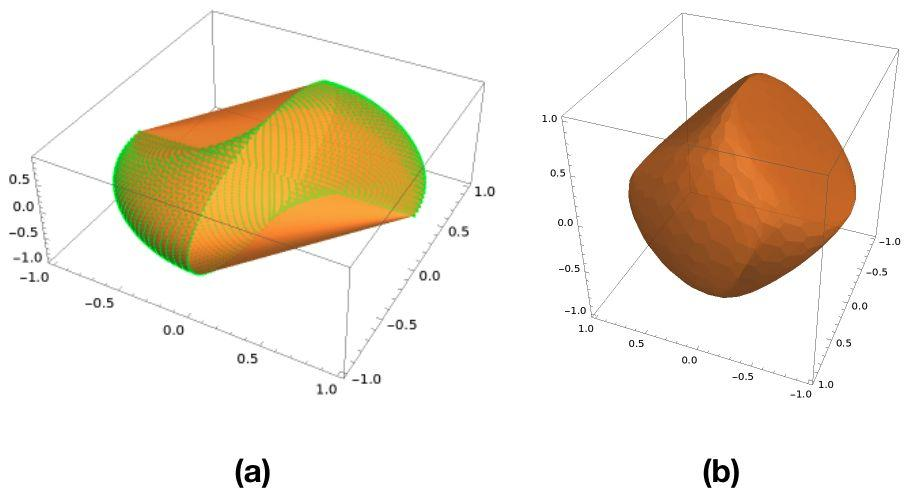What characteristic of the surface in Figure (a) distinguishes it from the surface in Figure (b)? A. Figure (a) has a flat surface, while Figure (b) has a curved surface. B. Figure (a) is a two-dimensional plot, while Figure (b) is a three-dimensional plot. C. Figure (a) shows a surface with only positive z-values, while Figure (b) includes both positive and negative z-values. D. Figure (a) shows a sinusoidal pattern, while Figure (b) is a solid without a visible pattern. Figure (a) displays a clear sinusoidal pattern across its surface, indicated by the alternating colors representing different heights (z-values), while Figure (b) shows a smooth, solid object without any visible pattern, just a single color indicating a single height level. Therefore, the correct answer is D. 